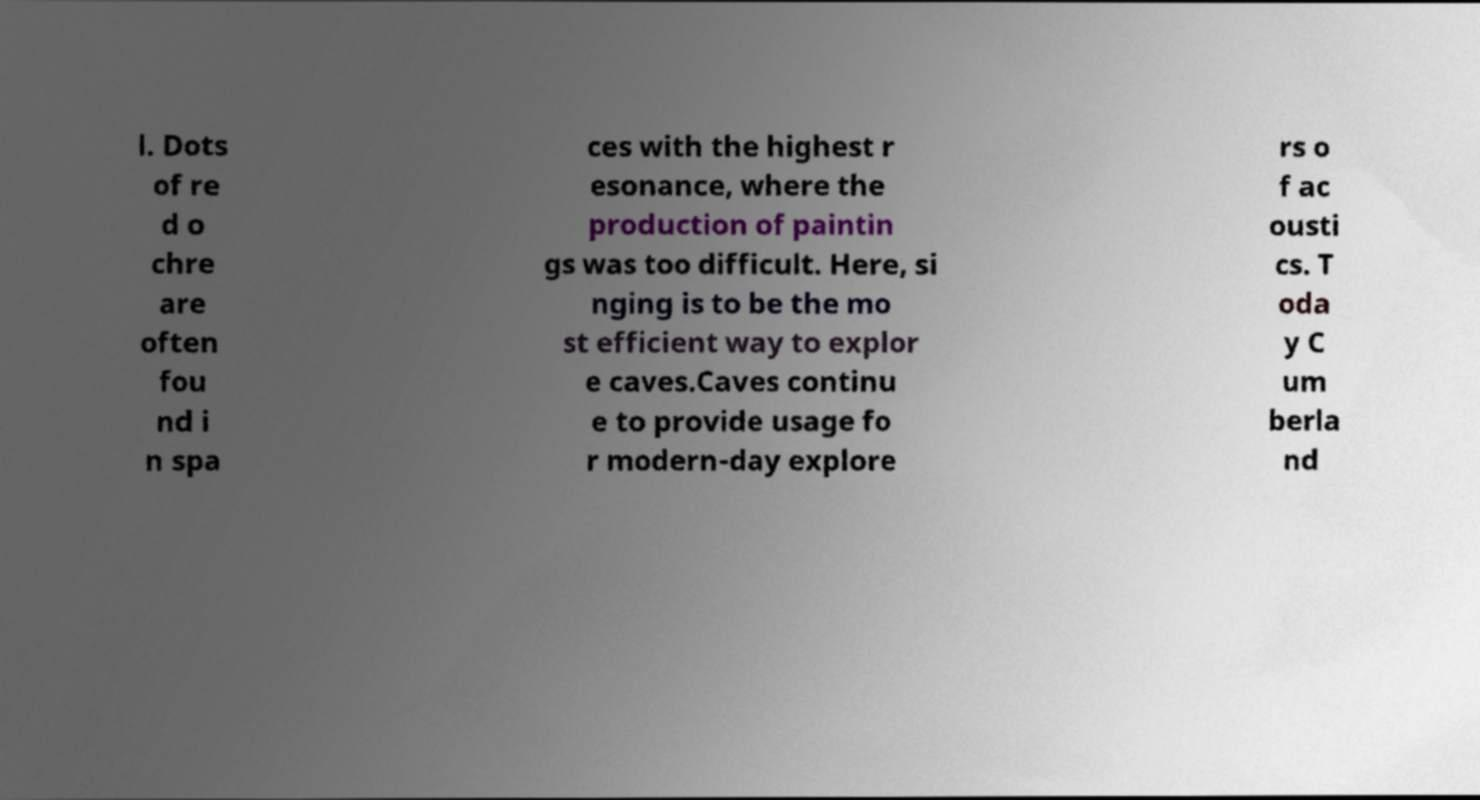Can you read and provide the text displayed in the image?This photo seems to have some interesting text. Can you extract and type it out for me? l. Dots of re d o chre are often fou nd i n spa ces with the highest r esonance, where the production of paintin gs was too difficult. Here, si nging is to be the mo st efficient way to explor e caves.Caves continu e to provide usage fo r modern-day explore rs o f ac ousti cs. T oda y C um berla nd 